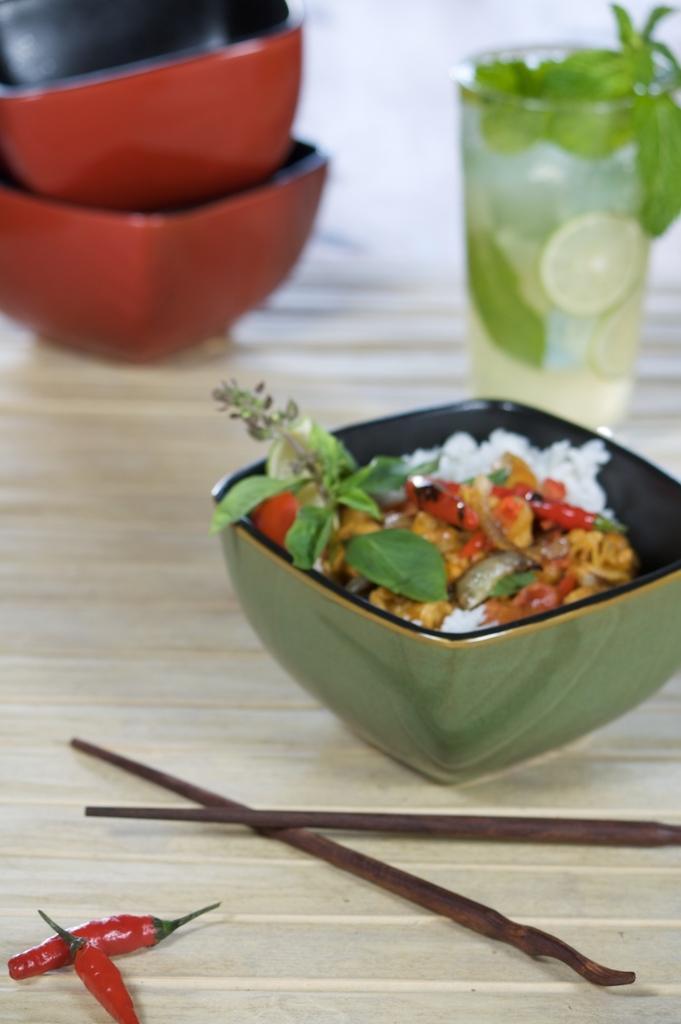Could you give a brief overview of what you see in this image? In this picture we can see a table, there are bowls, a glass of drink, chopsticks and red chillies present on the table, we can see some food in this bowl. 